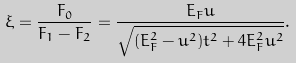Convert formula to latex. <formula><loc_0><loc_0><loc_500><loc_500>\xi = \frac { F _ { 0 } } { F _ { 1 } - F _ { 2 } } = \frac { E _ { F } u } { \sqrt { ( E _ { F } ^ { 2 } - u ^ { 2 } ) t ^ { 2 } + 4 E _ { F } ^ { 2 } u ^ { 2 } } } .</formula> 